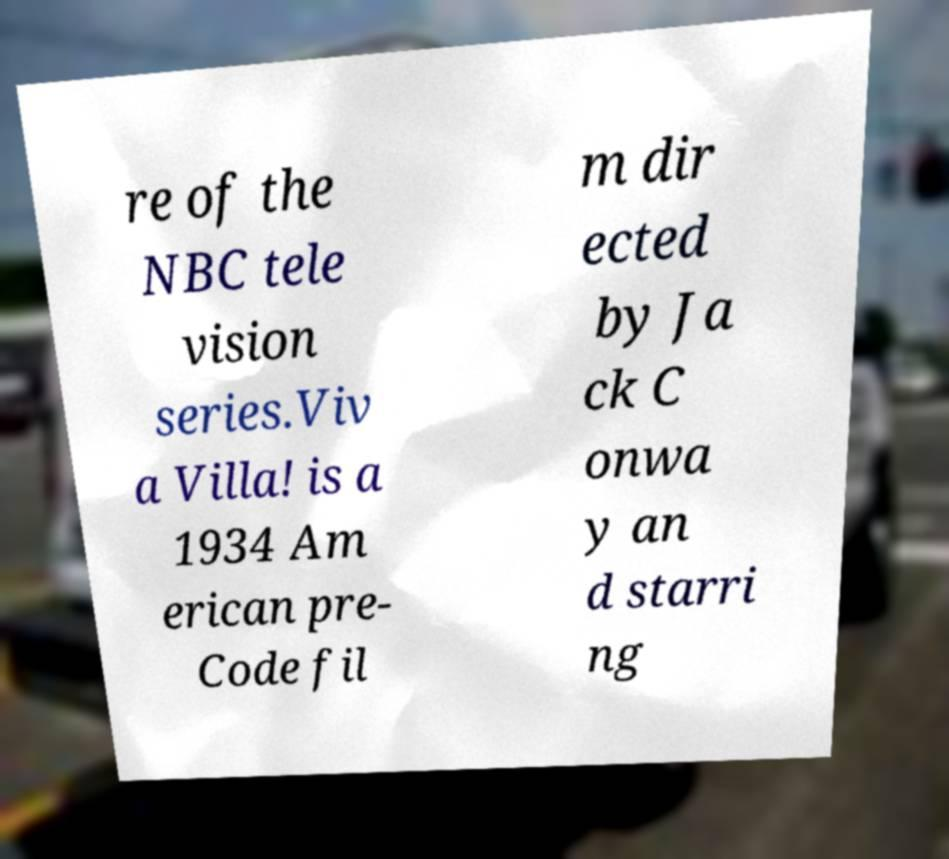For documentation purposes, I need the text within this image transcribed. Could you provide that? re of the NBC tele vision series.Viv a Villa! is a 1934 Am erican pre- Code fil m dir ected by Ja ck C onwa y an d starri ng 